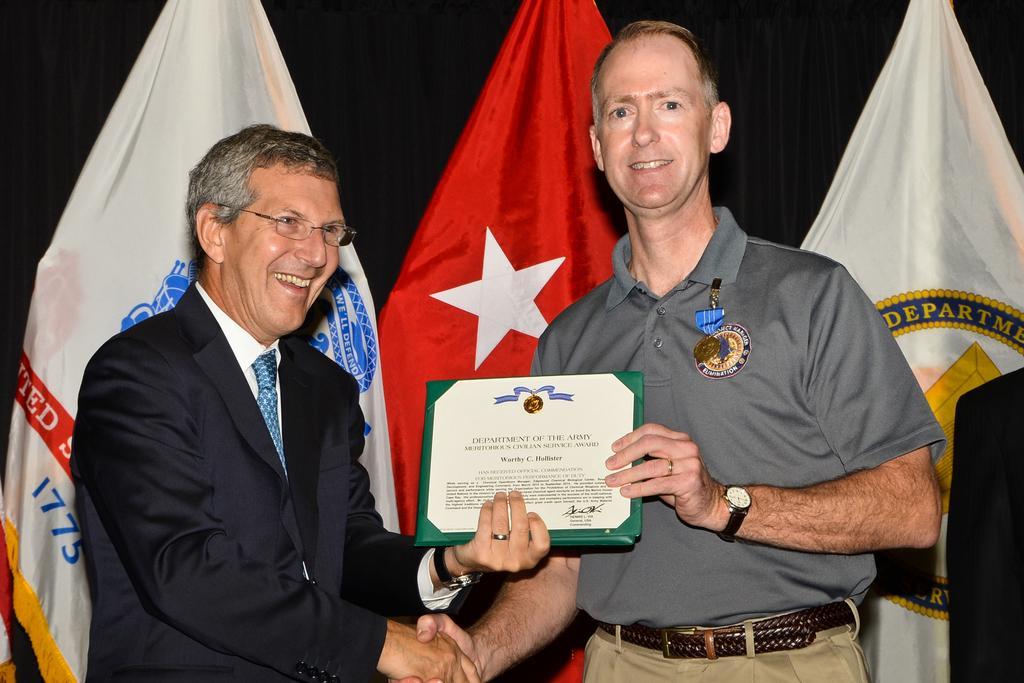In one or two sentences, can you explain what this image depicts? In this image I can see two men are standing and I can see both of them are holding a certificate. I can also see smile on their faces and I can see both of them are wearing watch. Here I can see he is wearing specs, suit, tie and white shirt. In the background I can see few flags. 